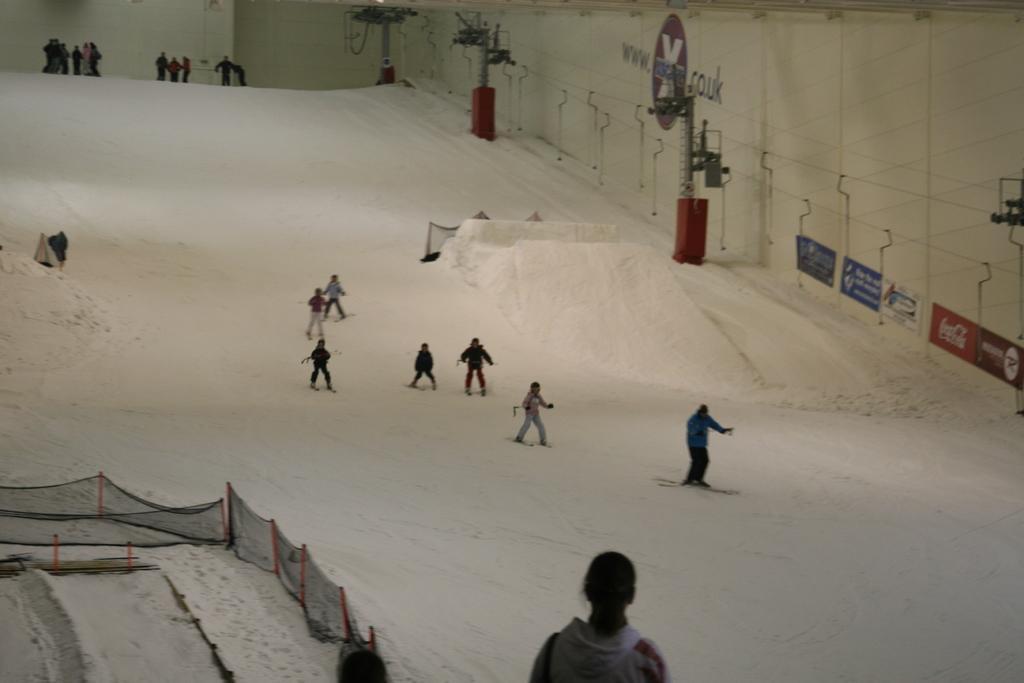Please provide a concise description of this image. In this image I can see few people are skating on the ice. To the left there is a railing. In the background there are some boards attached to the wall. 